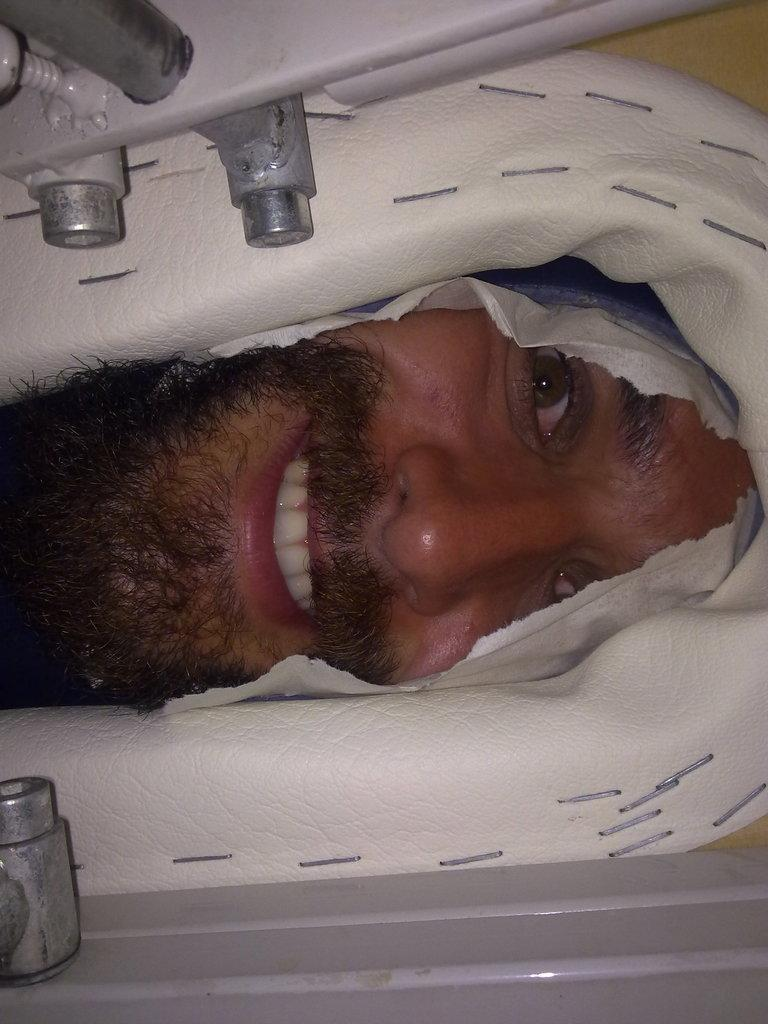What is the main subject of the image? There is a person in the image. What is the person doing in the image? The person is peeking through a hole. How does the person appear to feel in the image? The person is smiling. What type of pipe can be seen in the image? There is no pipe present in the image. What trick is the person performing in the image? There is no trick being performed in the image; the person is simply peeking through a hole. 